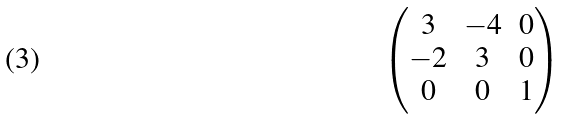Convert formula to latex. <formula><loc_0><loc_0><loc_500><loc_500>\begin{pmatrix} 3 & - 4 & 0 \\ - 2 & 3 & 0 \\ 0 & 0 & 1 \end{pmatrix}</formula> 